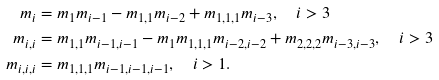<formula> <loc_0><loc_0><loc_500><loc_500>m _ { i } & = m _ { 1 } m _ { i - 1 } - m _ { 1 , 1 } m _ { i - 2 } + m _ { 1 , 1 , 1 } m _ { i - 3 } , \quad i > 3 \\ m _ { i , i } & = m _ { 1 , 1 } m _ { i - 1 , i - 1 } - m _ { 1 } m _ { 1 , 1 , 1 } m _ { i - 2 , i - 2 } + m _ { 2 , 2 , 2 } m _ { i - 3 , i - 3 } , \quad i > 3 \\ m _ { i , i , i } & = m _ { 1 , 1 , 1 } m _ { i - 1 , i - 1 , i - 1 } , \quad i > 1 .</formula> 